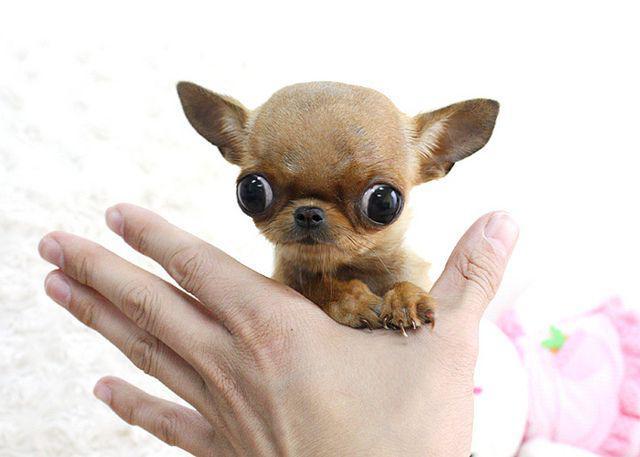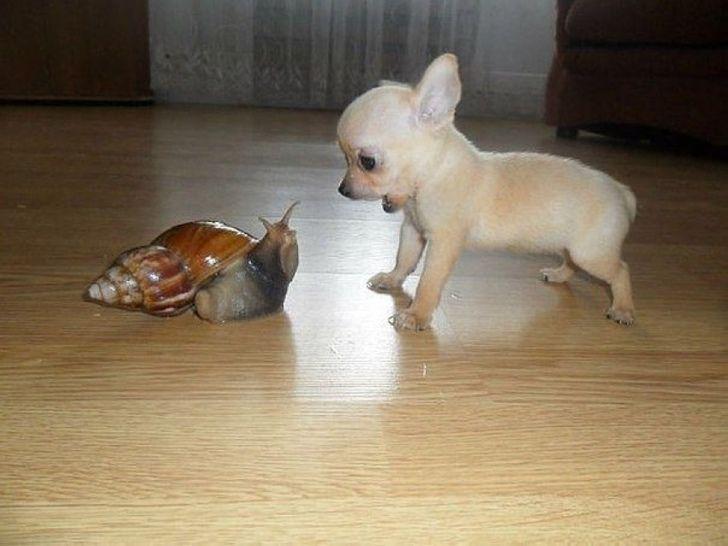The first image is the image on the left, the second image is the image on the right. Assess this claim about the two images: "In total, the images contain four dogs, but do not contain the same number of dogs in each image.". Correct or not? Answer yes or no. No. The first image is the image on the left, the second image is the image on the right. Analyze the images presented: Is the assertion "A person is holding the dog in one of the images." valid? Answer yes or no. Yes. 